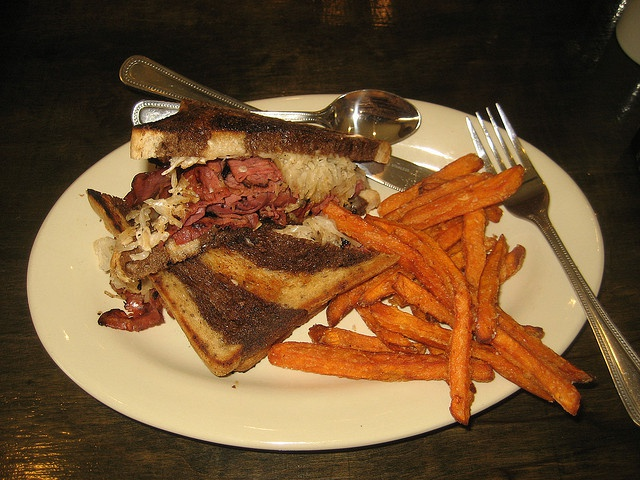Describe the objects in this image and their specific colors. I can see sandwich in black, maroon, brown, and tan tones, fork in black, olive, maroon, and tan tones, spoon in black, maroon, and ivory tones, and knife in black, maroon, brown, and gray tones in this image. 